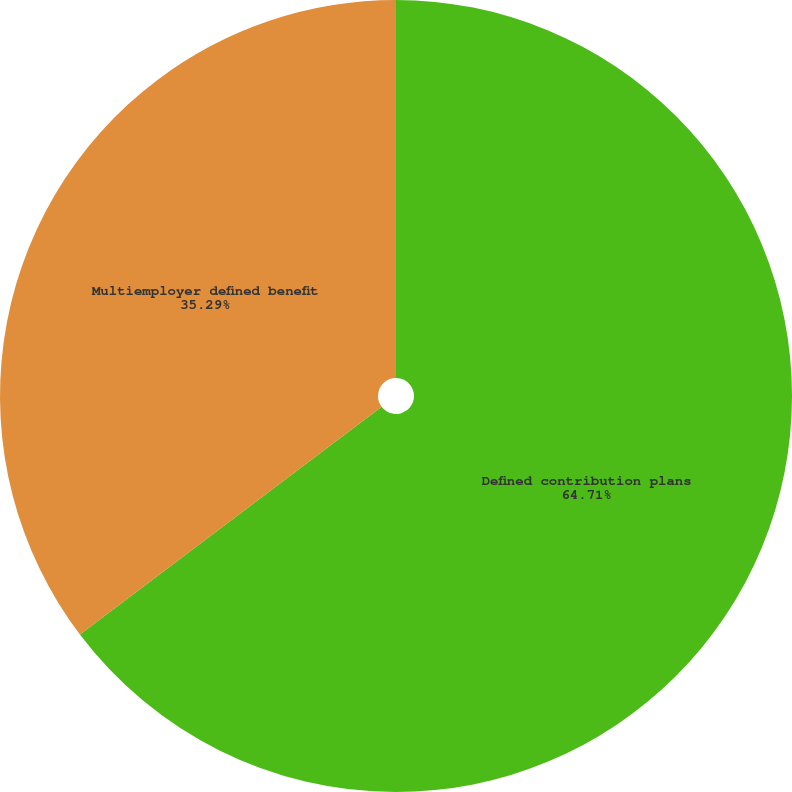Convert chart to OTSL. <chart><loc_0><loc_0><loc_500><loc_500><pie_chart><fcel>Defined contribution plans<fcel>Multiemployer defined benefit<nl><fcel>64.71%<fcel>35.29%<nl></chart> 